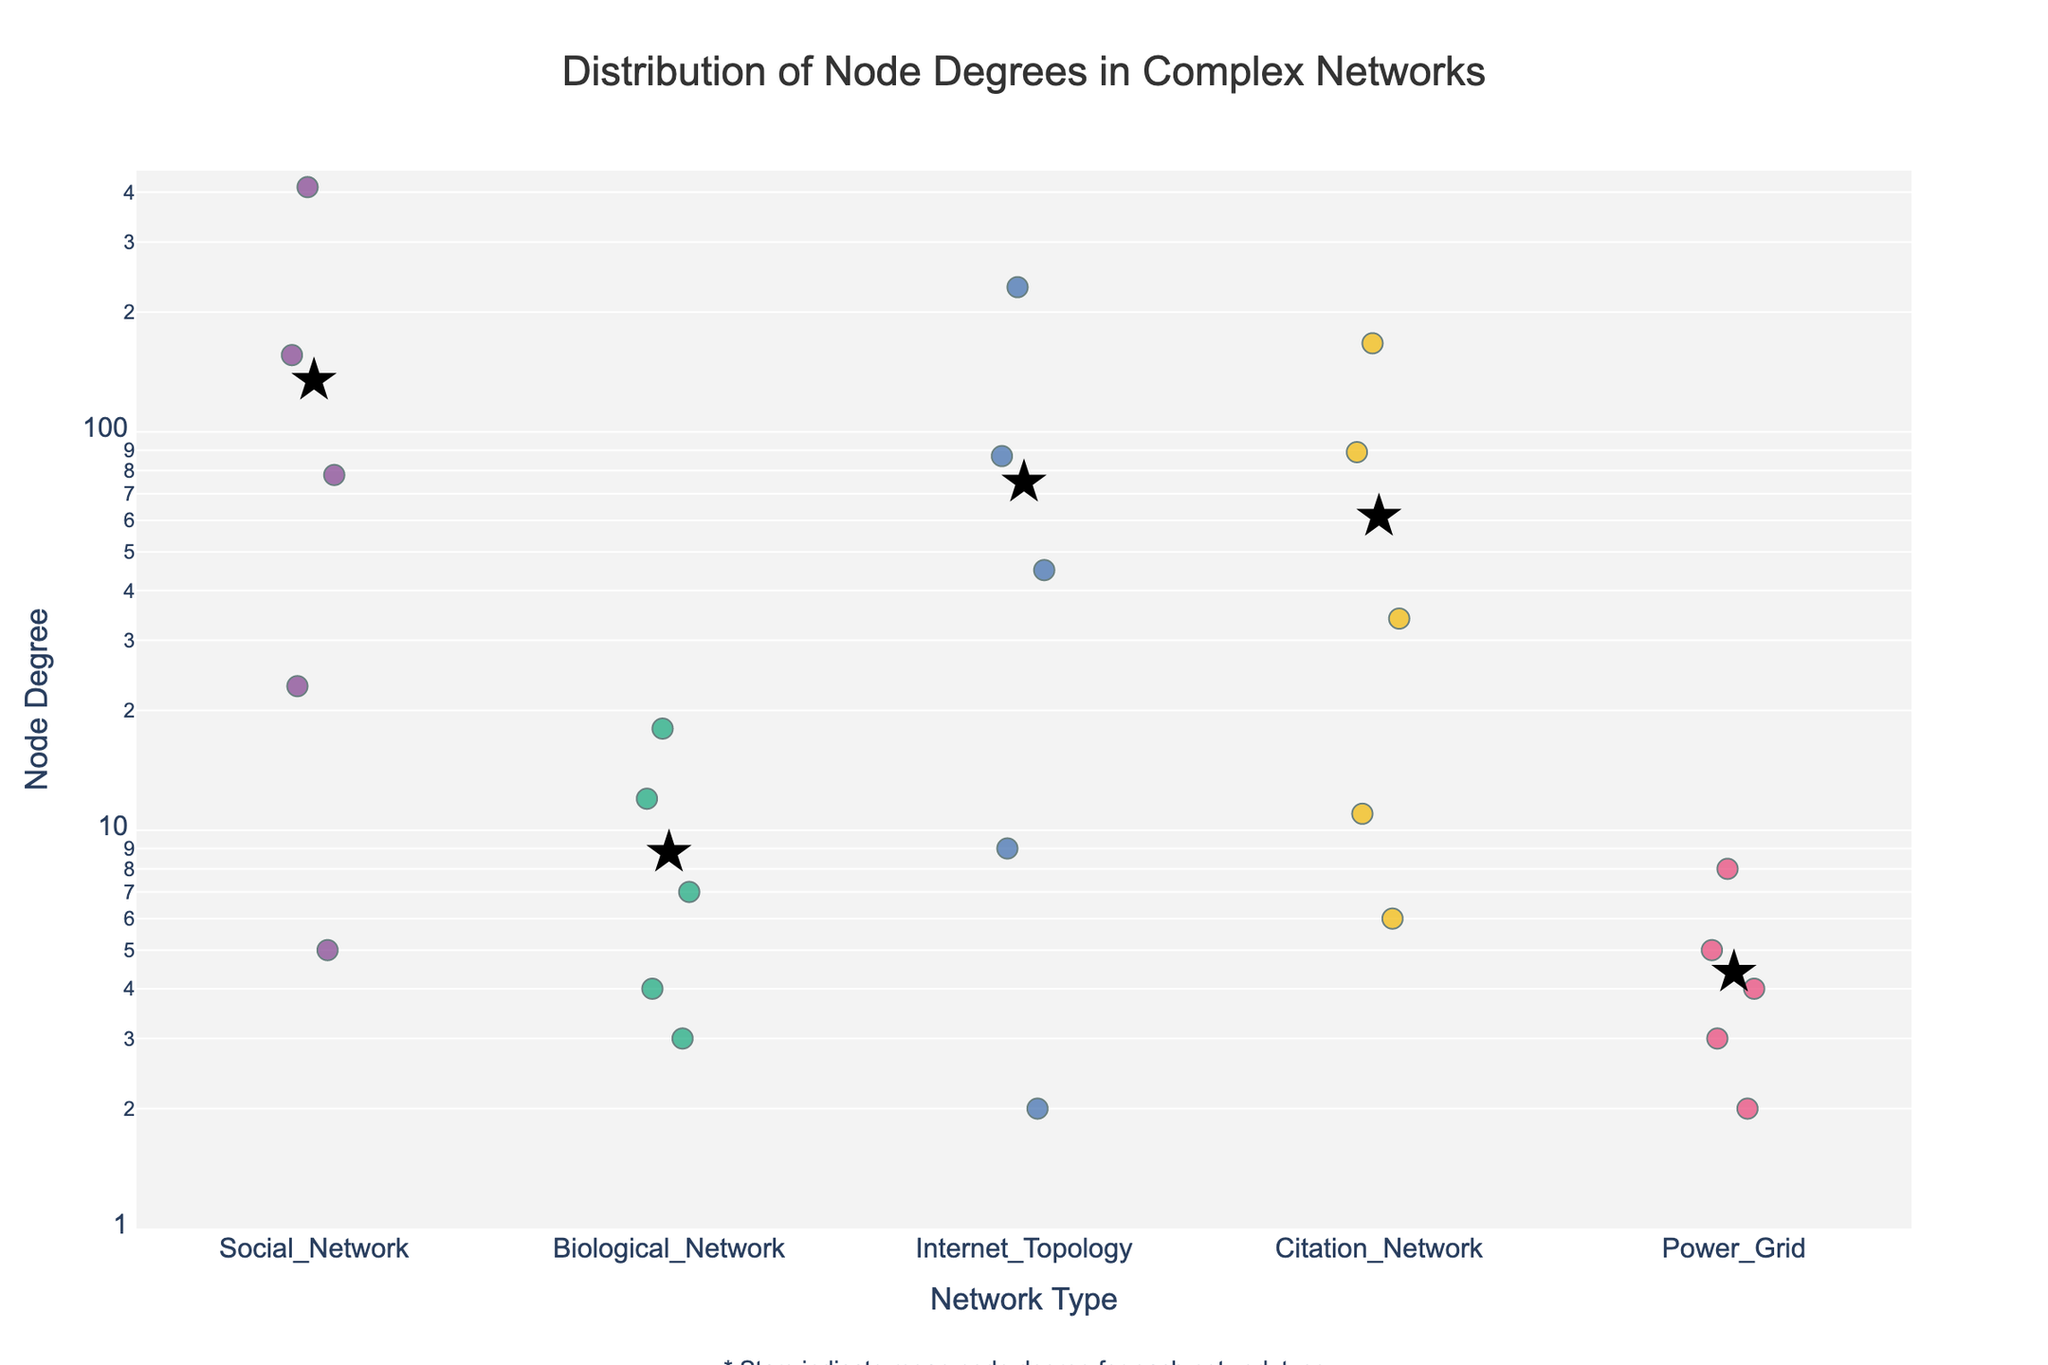What's the title of the plot? The title is located at the top center of the plot and is often the largest text, making it easy to identify. It reads "Distribution of Node Degrees in Complex Networks".
Answer: Distribution of Node Degrees in Complex Networks What is the node degree range for the Social Network? Look at the Social Network strip; the node degrees range from the smallest to the largest visible value. The smallest degree is 5, and the largest is 412.
Answer: 5 to 412 Which network type has the highest mean node degree? The stars represent the mean node degree for each network type. The position of the star for each network type gives the highest mean for the Citation Network.
Answer: Citation Network Which network type shows the smallest spread in node degrees? By observing the strip plots, the Power Grid has the smallest spread because its node degree values are closely clustered together.
Answer: Power Grid How does the node degree of 167 for the Citation Network compare to the other values in the same category? Within the Citation Network strip, 167 is the second highest value, surpassed only by 89.
Answer: Second highest What pattern can be observed about the node degrees in the Power Grid network? The points in the Power Grid network are relatively close to each other, ranging from 2 to 8, indicating low variability.
Answer: Low variability, range: 2 to 8 Between the Internet Topology and Biological Network, which has a wider node degree range? Comparing the two stripes, the Internet Topology ranges from 2 to 231, while the Biological Network ranges from 3 to 18. Thus, the Internet Topology has a wider range.
Answer: Internet Topology In the strip plot, how is the log scale on the y-axis beneficial? The log scale on the y-axis helps in visualizing the node degrees across different magnitudes, making differences in higher values more apparent and compresses the wide range of node degrees into a more manageable visualization scale.
Answer: It helps visualize wide ranges of values What does the presence of stars in the plot indicate? The stars on the plot indicate the mean node degree for each network type, providing a visual summary of the central tendency.
Answer: Mean node degree Which network type has the most extreme outlier in terms of node degree, and what is that value? The Social Network shows the most extreme outlier, with the highest node degree value of 412.
Answer: Social Network, 412 